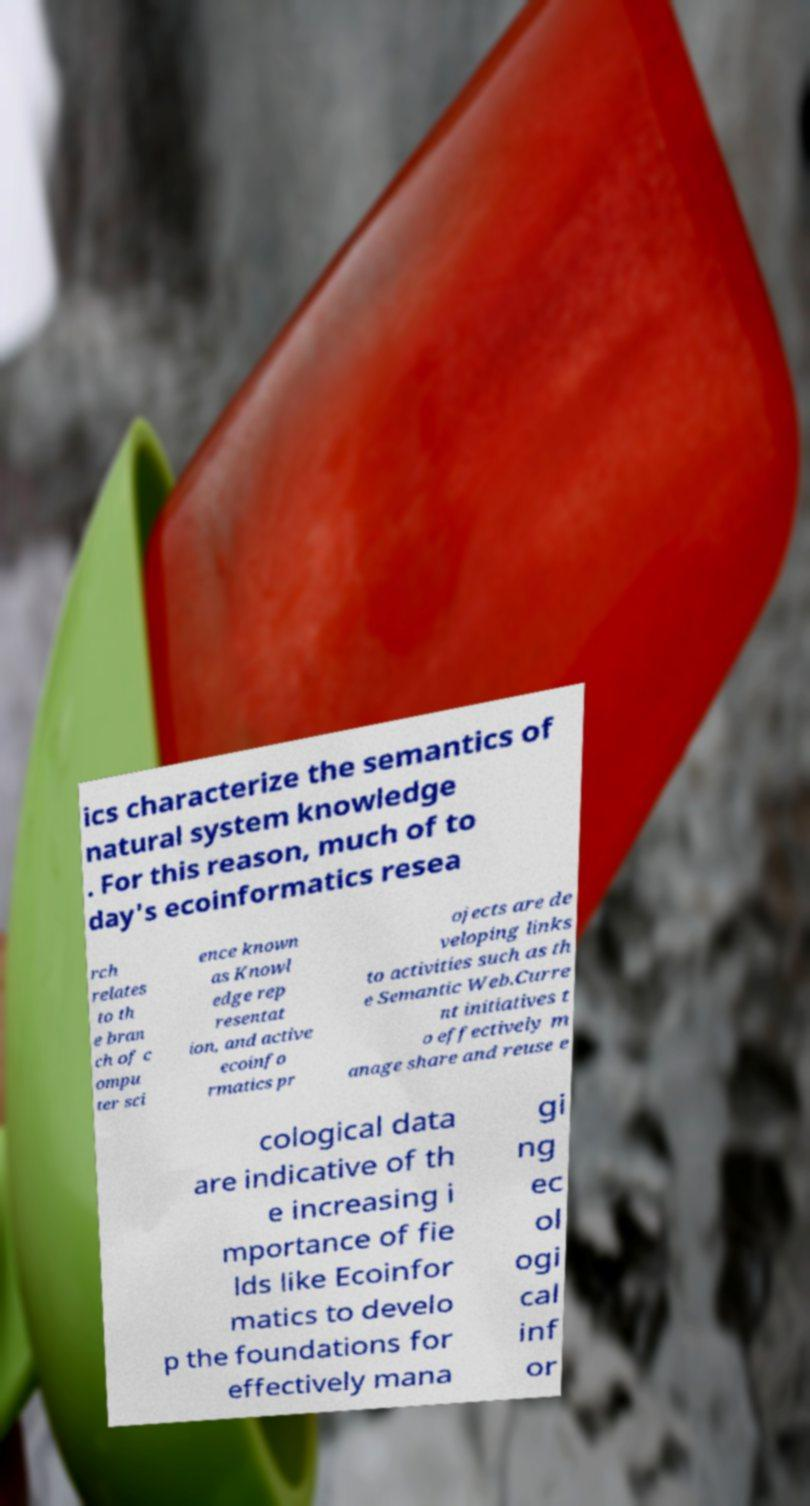Could you extract and type out the text from this image? ics characterize the semantics of natural system knowledge . For this reason, much of to day's ecoinformatics resea rch relates to th e bran ch of c ompu ter sci ence known as Knowl edge rep resentat ion, and active ecoinfo rmatics pr ojects are de veloping links to activities such as th e Semantic Web.Curre nt initiatives t o effectively m anage share and reuse e cological data are indicative of th e increasing i mportance of fie lds like Ecoinfor matics to develo p the foundations for effectively mana gi ng ec ol ogi cal inf or 